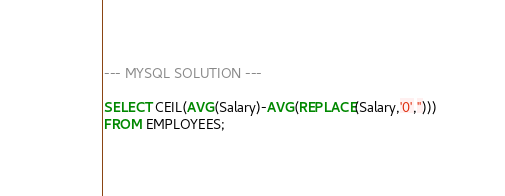Convert code to text. <code><loc_0><loc_0><loc_500><loc_500><_SQL_>--- MYSQL SOLUTION ---

SELECT CEIL(AVG(Salary)-AVG(REPLACE(Salary,'0',''))) 
FROM EMPLOYEES;</code> 